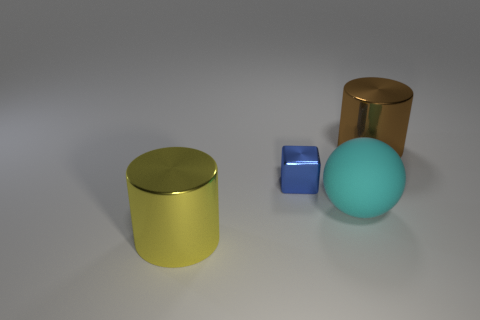Add 2 blue cubes. How many objects exist? 6 Subtract all balls. How many objects are left? 3 Subtract all cyan metal cylinders. Subtract all brown objects. How many objects are left? 3 Add 2 blue objects. How many blue objects are left? 3 Add 2 large yellow matte blocks. How many large yellow matte blocks exist? 2 Subtract 0 green spheres. How many objects are left? 4 